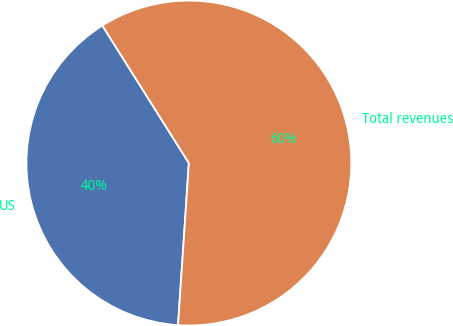Convert chart to OTSL. <chart><loc_0><loc_0><loc_500><loc_500><pie_chart><fcel>US<fcel>Total revenues<nl><fcel>40.0%<fcel>60.0%<nl></chart> 